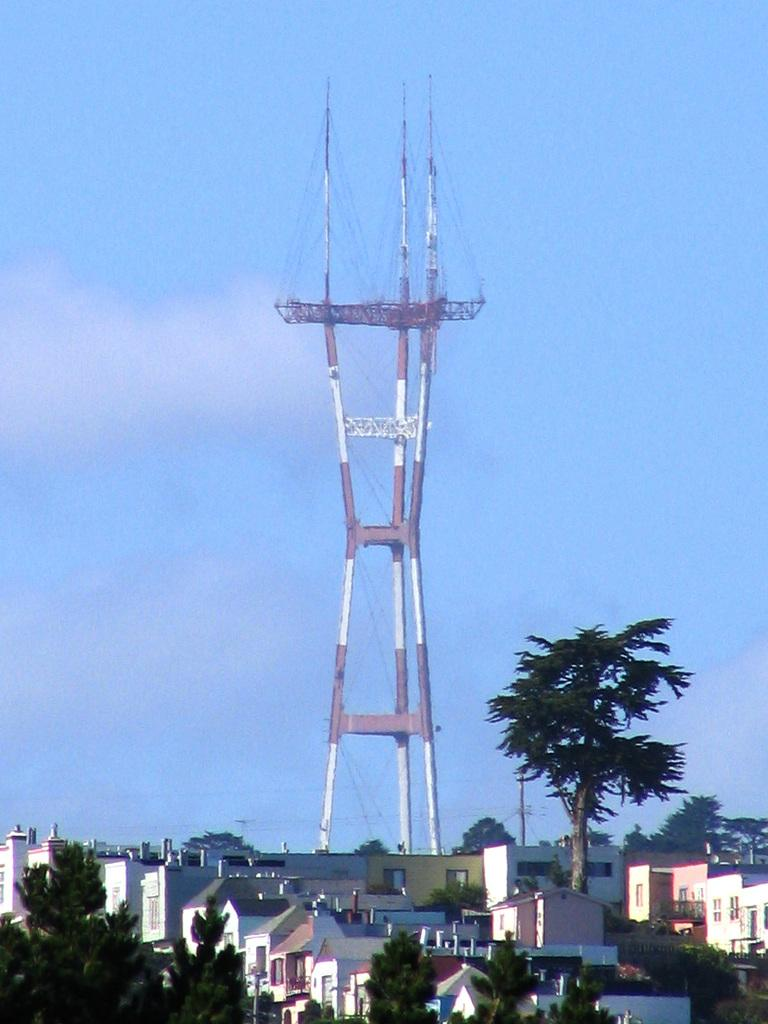What type of location is depicted in the image? The image is of a city. What structures can be seen in the city? There are buildings and a tower in the image. Are there any natural elements present in the city? Yes, there are trees in the image. What is attached to the tower? There are wires on the tower. What is visible at the top of the image? The sky is visible at the top of the image, and there are clouds in the sky. What type of feeling can be seen on the border of the image? There is no feeling or emotion depicted in the image, nor is there a border present. 